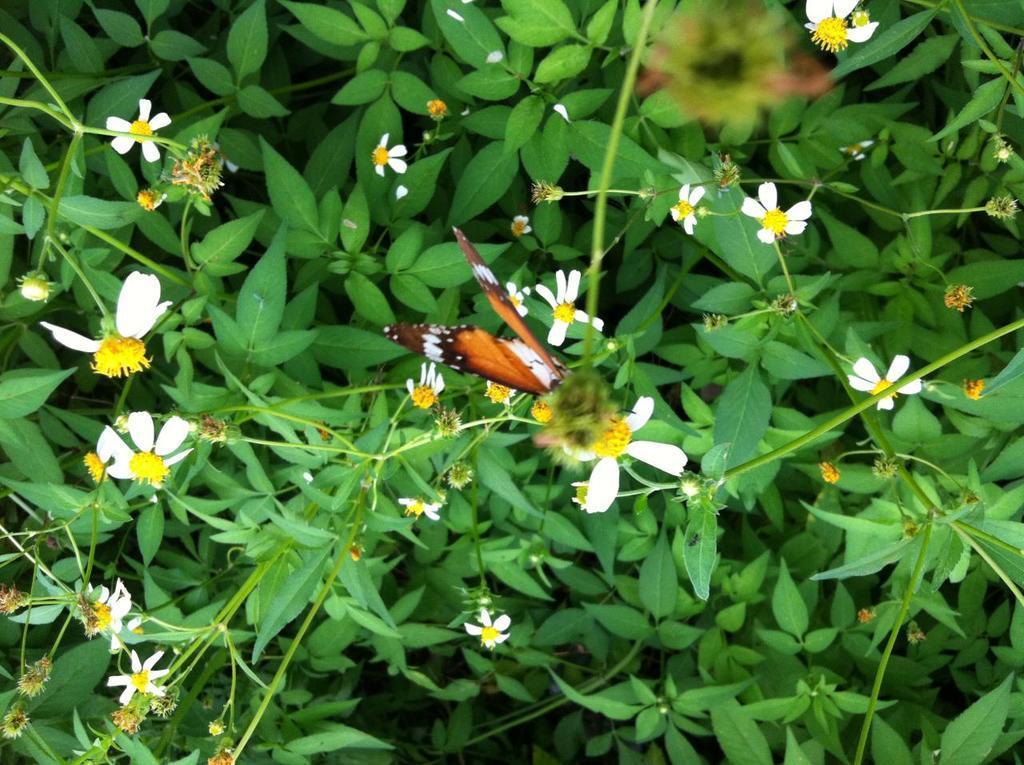Could you give a brief overview of what you see in this image? In this image there are few plants having few flowers and buds. Flowers are in white in colour. A butterfly is on the flower. 